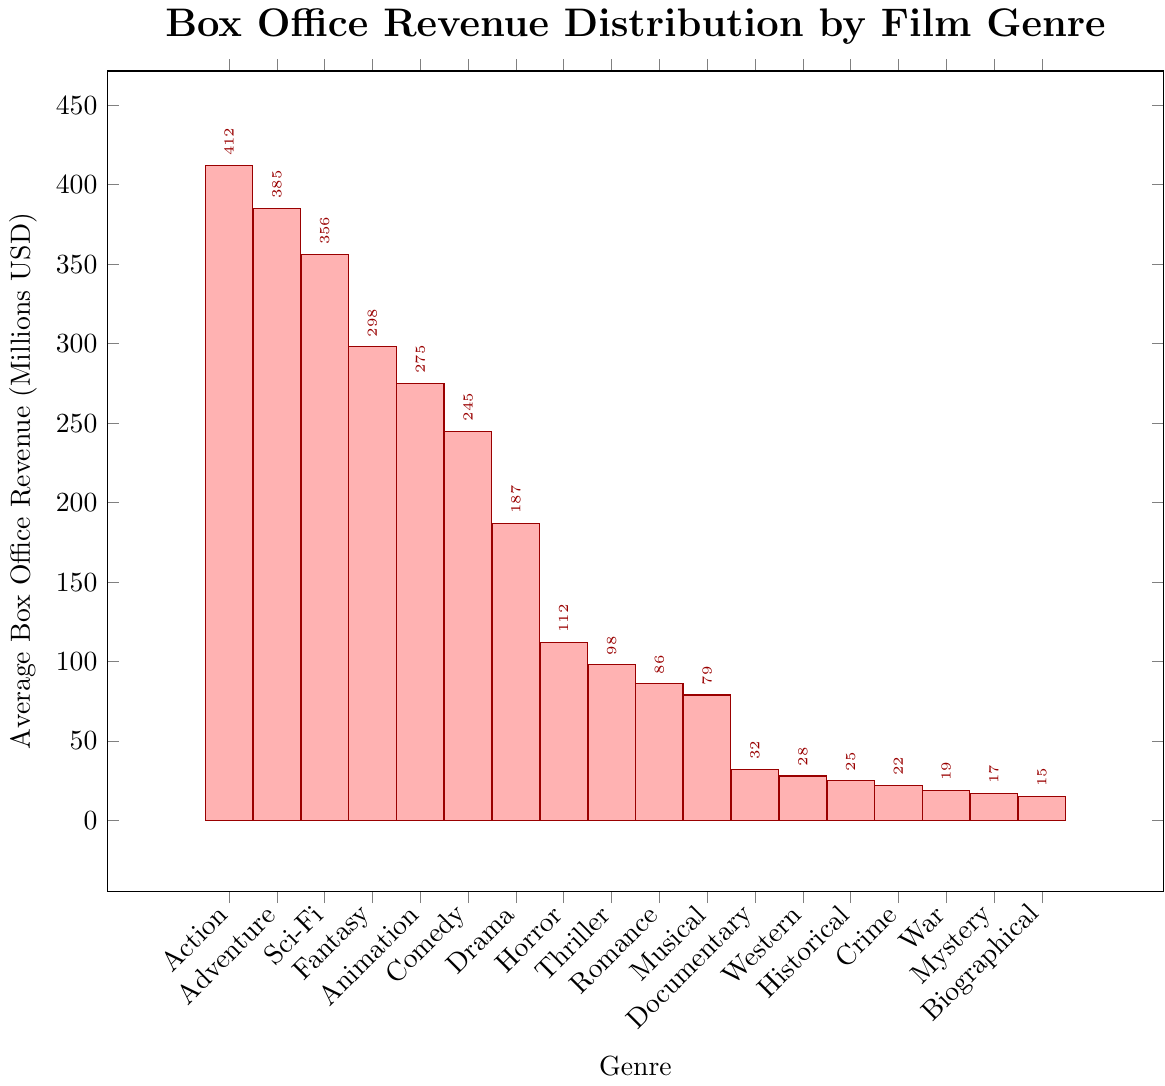Which genre has the highest average box office revenue? The tallest bar in the chart corresponds to the Action genre, which has the highest average box office revenue.
Answer: Action Which genre has the lowest average box office revenue? The shortest bar in the chart corresponds to the Biographical genre, which has the lowest average box office revenue.
Answer: Biographical What is the difference in average box office revenue between the top two genres? The top two genres are Action at 412 million USD and Adventure at 385 million USD. The difference is 412 - 385.
Answer: 27 million USD What is the combined average box office revenue for Fantasy, Animation, and Comedy genres? The average box office revenues are: Fantasy (298 million USD), Animation (275 million USD), and Comedy (245 million USD). The combined revenue is 298 + 275 + 245.
Answer: 818 million USD How do the revenues of Sci-Fi and Drama genres compare? Sci-Fi has an average box office revenue of 356 million USD, while Drama has 187 million USD. Sci-Fi's revenue is significantly higher than Drama's.
Answer: Sci-Fi > Drama Which genre earned slightly less than 100 million USD on average? The bar representing Thriller genre falls just below the 100 million USD mark.
Answer: Thriller Between Horror and Documentary genres, which has a higher average box office revenue, and by how much? Horror has an average box office revenue of 112 million USD, while Documentary has 32 million USD. The difference is 112 - 32.
Answer: Horror by 80 million USD Calculate the average of the highest and lowest genre revenues. The highest average box office revenue is for Action (412 million USD), and the lowest is for Biographical (15 million USD). The average of these two values is (412 + 15) / 2.
Answer: 213.5 million USD Is the average box office revenue for the Western genre more or less than half of the average for Fantasy genre? The Western genre has an average of 28 million USD. Half of the average for Fantasy, which is 298 million USD, is 298 / 2 = 149 million USD. Since 28 is less than 149, it is less than half.
Answer: Less 